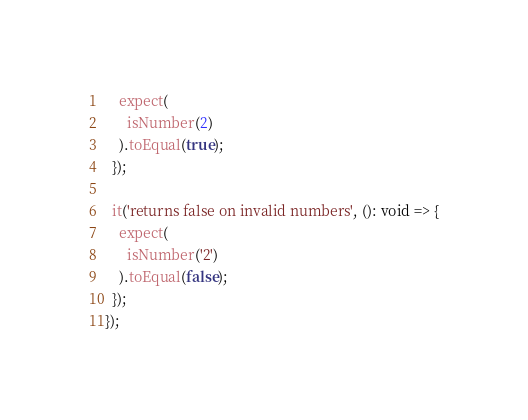Convert code to text. <code><loc_0><loc_0><loc_500><loc_500><_TypeScript_>    expect(
      isNumber(2)
    ).toEqual(true);
  });

  it('returns false on invalid numbers', (): void => {
    expect(
      isNumber('2')
    ).toEqual(false);
  });
});
</code> 